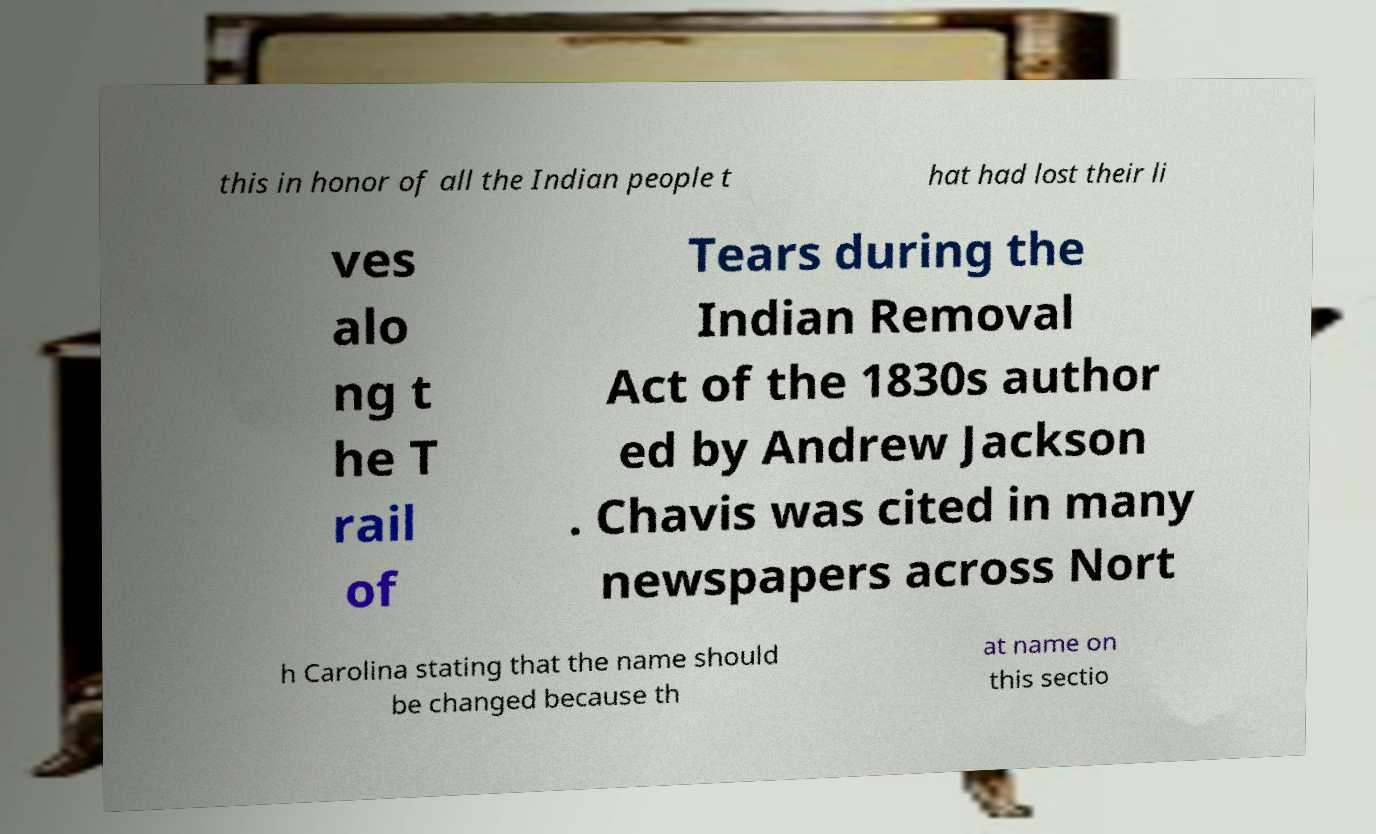Can you accurately transcribe the text from the provided image for me? this in honor of all the Indian people t hat had lost their li ves alo ng t he T rail of Tears during the Indian Removal Act of the 1830s author ed by Andrew Jackson . Chavis was cited in many newspapers across Nort h Carolina stating that the name should be changed because th at name on this sectio 